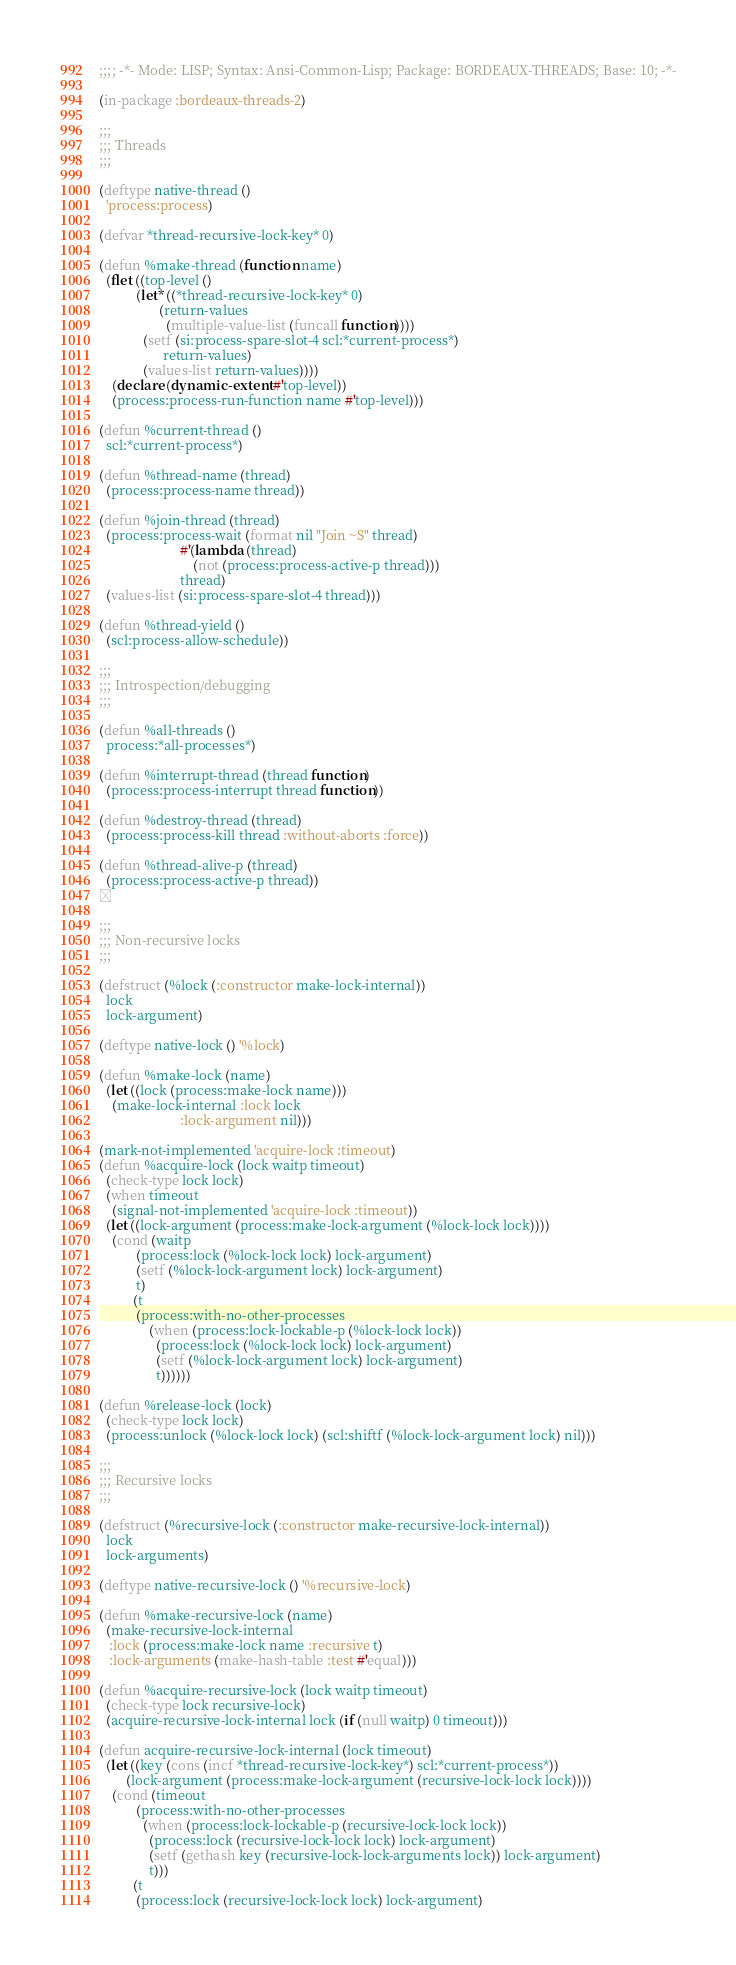<code> <loc_0><loc_0><loc_500><loc_500><_Lisp_>;;;; -*- Mode: LISP; Syntax: Ansi-Common-Lisp; Package: BORDEAUX-THREADS; Base: 10; -*-

(in-package :bordeaux-threads-2)

;;;
;;; Threads
;;;

(deftype native-thread ()
  'process:process)

(defvar *thread-recursive-lock-key* 0)

(defun %make-thread (function name)
  (flet ((top-level ()
           (let* ((*thread-recursive-lock-key* 0)
                  (return-values
                    (multiple-value-list (funcall function))))
             (setf (si:process-spare-slot-4 scl:*current-process*)
                   return-values)
             (values-list return-values))))
    (declare (dynamic-extent #'top-level))
    (process:process-run-function name #'top-level)))

(defun %current-thread ()
  scl:*current-process*)

(defun %thread-name (thread)
  (process:process-name thread))

(defun %join-thread (thread)
  (process:process-wait (format nil "Join ~S" thread)
                        #'(lambda (thread)
                            (not (process:process-active-p thread)))
                        thread)
  (values-list (si:process-spare-slot-4 thread)))

(defun %thread-yield ()
  (scl:process-allow-schedule))

;;;
;;; Introspection/debugging
;;;

(defun %all-threads ()
  process:*all-processes*)

(defun %interrupt-thread (thread function)
  (process:process-interrupt thread function))

(defun %destroy-thread (thread)
  (process:process-kill thread :without-aborts :force))

(defun %thread-alive-p (thread)
  (process:process-active-p thread))


;;;
;;; Non-recursive locks
;;;

(defstruct (%lock (:constructor make-lock-internal))
  lock
  lock-argument)

(deftype native-lock () '%lock)

(defun %make-lock (name)
  (let ((lock (process:make-lock name)))
    (make-lock-internal :lock lock
                        :lock-argument nil)))

(mark-not-implemented 'acquire-lock :timeout)
(defun %acquire-lock (lock waitp timeout)
  (check-type lock lock)
  (when timeout
    (signal-not-implemented 'acquire-lock :timeout))
  (let ((lock-argument (process:make-lock-argument (%lock-lock lock))))
    (cond (waitp
           (process:lock (%lock-lock lock) lock-argument)
           (setf (%lock-lock-argument lock) lock-argument)
           t)
          (t
           (process:with-no-other-processes
               (when (process:lock-lockable-p (%lock-lock lock))
                 (process:lock (%lock-lock lock) lock-argument)
                 (setf (%lock-lock-argument lock) lock-argument)
                 t))))))

(defun %release-lock (lock)
  (check-type lock lock)
  (process:unlock (%lock-lock lock) (scl:shiftf (%lock-lock-argument lock) nil)))

;;;
;;; Recursive locks
;;;

(defstruct (%recursive-lock (:constructor make-recursive-lock-internal))
  lock
  lock-arguments)

(deftype native-recursive-lock () '%recursive-lock)

(defun %make-recursive-lock (name)
  (make-recursive-lock-internal
   :lock (process:make-lock name :recursive t)
   :lock-arguments (make-hash-table :test #'equal)))

(defun %acquire-recursive-lock (lock waitp timeout)
  (check-type lock recursive-lock)
  (acquire-recursive-lock-internal lock (if (null waitp) 0 timeout)))

(defun acquire-recursive-lock-internal (lock timeout)
  (let ((key (cons (incf *thread-recursive-lock-key*) scl:*current-process*))
        (lock-argument (process:make-lock-argument (recursive-lock-lock lock))))
    (cond (timeout
           (process:with-no-other-processes
             (when (process:lock-lockable-p (recursive-lock-lock lock))
               (process:lock (recursive-lock-lock lock) lock-argument)
               (setf (gethash key (recursive-lock-lock-arguments lock)) lock-argument)
               t)))
          (t
           (process:lock (recursive-lock-lock lock) lock-argument)</code> 